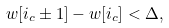Convert formula to latex. <formula><loc_0><loc_0><loc_500><loc_500>w [ i _ { c } \pm 1 ] - w [ i _ { c } ] < \Delta ,</formula> 